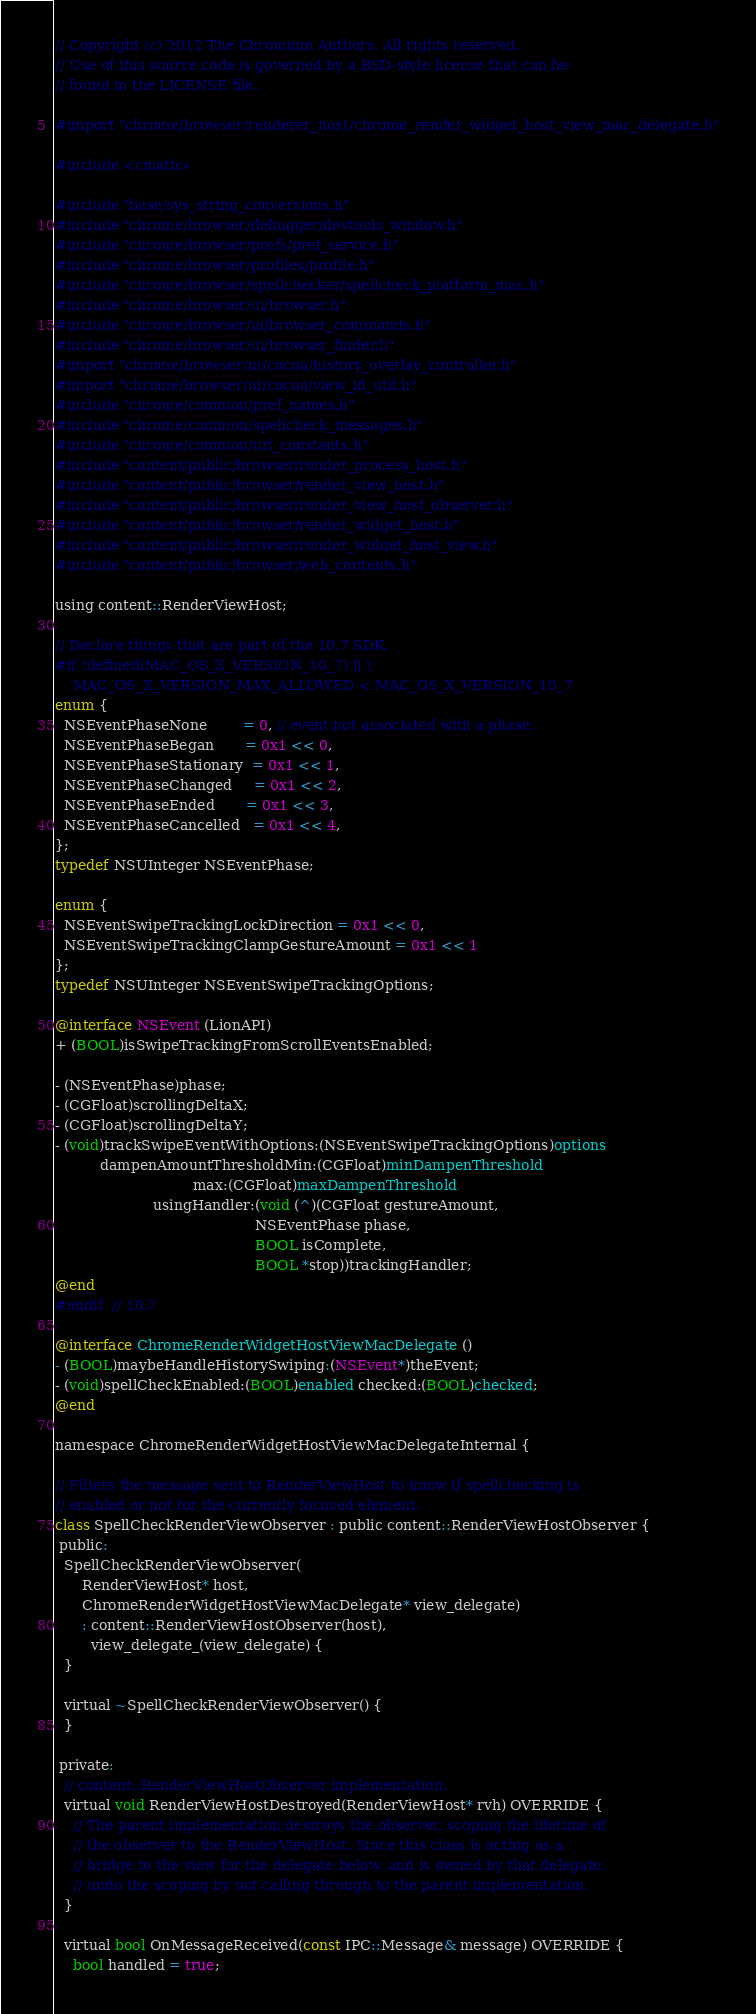Convert code to text. <code><loc_0><loc_0><loc_500><loc_500><_ObjectiveC_>// Copyright (c) 2012 The Chromium Authors. All rights reserved.
// Use of this source code is governed by a BSD-style license that can be
// found in the LICENSE file.

#import "chrome/browser/renderer_host/chrome_render_widget_host_view_mac_delegate.h"

#include <cmath>

#include "base/sys_string_conversions.h"
#include "chrome/browser/debugger/devtools_window.h"
#include "chrome/browser/prefs/pref_service.h"
#include "chrome/browser/profiles/profile.h"
#include "chrome/browser/spellchecker/spellcheck_platform_mac.h"
#include "chrome/browser/ui/browser.h"
#include "chrome/browser/ui/browser_commands.h"
#include "chrome/browser/ui/browser_finder.h"
#import "chrome/browser/ui/cocoa/history_overlay_controller.h"
#import "chrome/browser/ui/cocoa/view_id_util.h"
#include "chrome/common/pref_names.h"
#include "chrome/common/spellcheck_messages.h"
#include "chrome/common/url_constants.h"
#include "content/public/browser/render_process_host.h"
#include "content/public/browser/render_view_host.h"
#include "content/public/browser/render_view_host_observer.h"
#include "content/public/browser/render_widget_host.h"
#include "content/public/browser/render_widget_host_view.h"
#include "content/public/browser/web_contents.h"

using content::RenderViewHost;

// Declare things that are part of the 10.7 SDK.
#if !defined(MAC_OS_X_VERSION_10_7) || \
    MAC_OS_X_VERSION_MAX_ALLOWED < MAC_OS_X_VERSION_10_7
enum {
  NSEventPhaseNone        = 0, // event not associated with a phase.
  NSEventPhaseBegan       = 0x1 << 0,
  NSEventPhaseStationary  = 0x1 << 1,
  NSEventPhaseChanged     = 0x1 << 2,
  NSEventPhaseEnded       = 0x1 << 3,
  NSEventPhaseCancelled   = 0x1 << 4,
};
typedef NSUInteger NSEventPhase;

enum {
  NSEventSwipeTrackingLockDirection = 0x1 << 0,
  NSEventSwipeTrackingClampGestureAmount = 0x1 << 1
};
typedef NSUInteger NSEventSwipeTrackingOptions;

@interface NSEvent (LionAPI)
+ (BOOL)isSwipeTrackingFromScrollEventsEnabled;

- (NSEventPhase)phase;
- (CGFloat)scrollingDeltaX;
- (CGFloat)scrollingDeltaY;
- (void)trackSwipeEventWithOptions:(NSEventSwipeTrackingOptions)options
          dampenAmountThresholdMin:(CGFloat)minDampenThreshold
                               max:(CGFloat)maxDampenThreshold
                      usingHandler:(void (^)(CGFloat gestureAmount,
                                             NSEventPhase phase,
                                             BOOL isComplete,
                                             BOOL *stop))trackingHandler;
@end
#endif  // 10.7

@interface ChromeRenderWidgetHostViewMacDelegate ()
- (BOOL)maybeHandleHistorySwiping:(NSEvent*)theEvent;
- (void)spellCheckEnabled:(BOOL)enabled checked:(BOOL)checked;
@end

namespace ChromeRenderWidgetHostViewMacDelegateInternal {

// Filters the message sent to RenderViewHost to know if spellchecking is
// enabled or not for the currently focused element.
class SpellCheckRenderViewObserver : public content::RenderViewHostObserver {
 public:
  SpellCheckRenderViewObserver(
      RenderViewHost* host,
      ChromeRenderWidgetHostViewMacDelegate* view_delegate)
      : content::RenderViewHostObserver(host),
        view_delegate_(view_delegate) {
  }

  virtual ~SpellCheckRenderViewObserver() {
  }

 private:
  // content::RenderViewHostObserver implementation.
  virtual void RenderViewHostDestroyed(RenderViewHost* rvh) OVERRIDE {
    // The parent implementation destroys the observer, scoping the lifetime of
    // the observer to the RenderViewHost. Since this class is acting as a
    // bridge to the view for the delegate below, and is owned by that delegate,
    // undo the scoping by not calling through to the parent implementation.
  }

  virtual bool OnMessageReceived(const IPC::Message& message) OVERRIDE {
    bool handled = true;</code> 